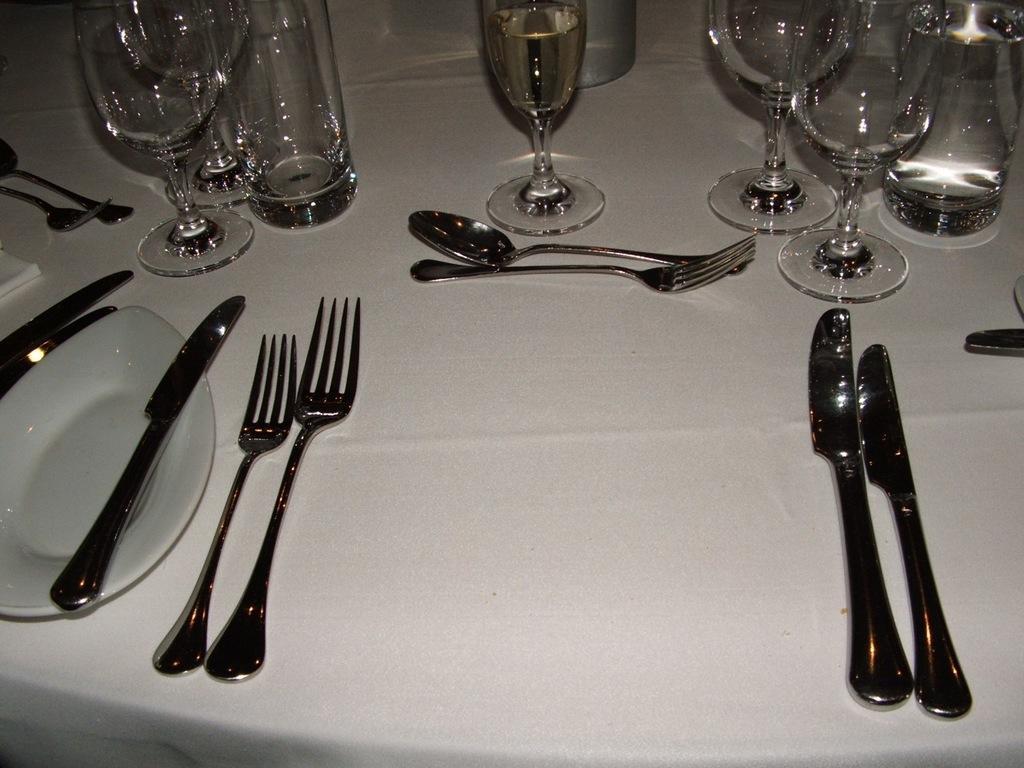Could you give a brief overview of what you see in this image? In this image there is a table with a table cloth, a few knives, spoons, forks, glasses, bottles, a tissue paper and a plate on it. 